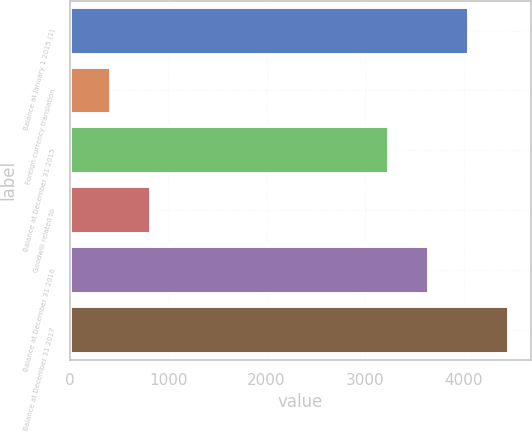Convert chart to OTSL. <chart><loc_0><loc_0><loc_500><loc_500><bar_chart><fcel>Balance at January 1 2015 (1)<fcel>Foreign currency translation<fcel>Balance at December 31 2015<fcel>Goodwill related to<fcel>Balance at December 31 2016<fcel>Balance at December 31 2017<nl><fcel>4057.6<fcel>416.3<fcel>3243<fcel>823.6<fcel>3650.3<fcel>4464.9<nl></chart> 